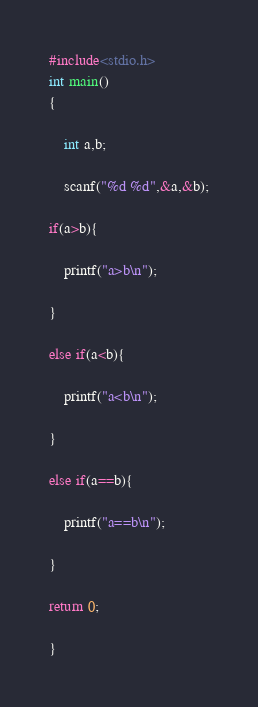Convert code to text. <code><loc_0><loc_0><loc_500><loc_500><_C_>#include<stdio.h>
int main()
{

	int a,b;

	scanf("%d %d",&a,&b);

if(a>b){

	printf("a>b\n");

}

else if(a<b){

	printf("a<b\n");

}

else if(a==b){

	printf("a==b\n");

}

return 0;

}</code> 